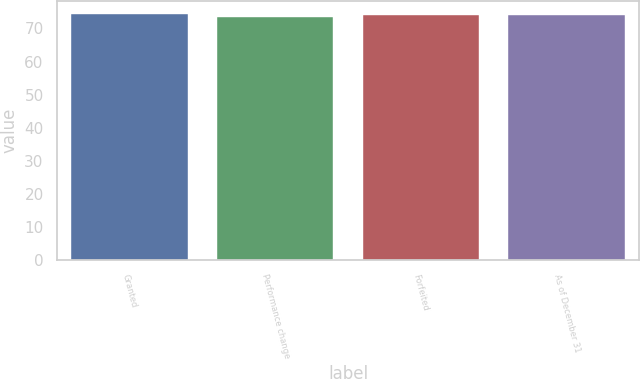Convert chart. <chart><loc_0><loc_0><loc_500><loc_500><bar_chart><fcel>Granted<fcel>Performance change<fcel>Forfeited<fcel>As of December 31<nl><fcel>74.46<fcel>73.55<fcel>73.92<fcel>74.01<nl></chart> 